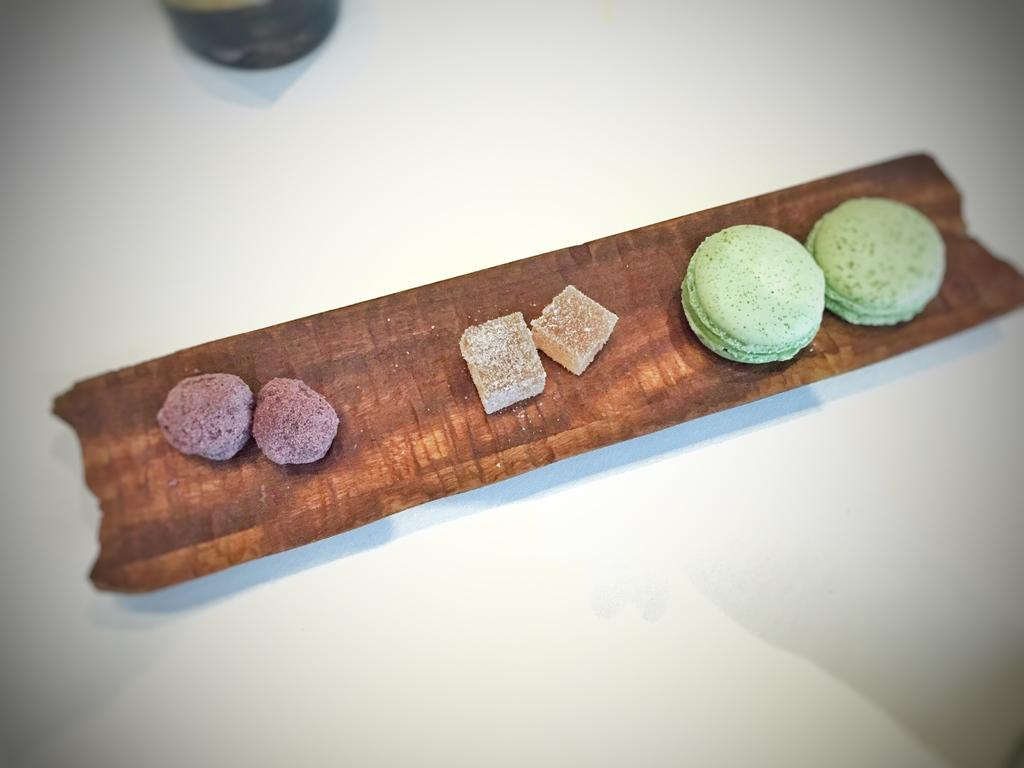What type of food can be seen in the image? There are cookies in the image. How are the cookies arranged or presented? The cookies are in a wooden tray. Where is the wooden tray with cookies located? The tray is on a table. What else can be seen on the table besides the cookies? There is a bottle visible in the image. What type of animal can be heard making a voice in the image? There is no animal or voice present in the image; it only shows cookies in a wooden tray on a table. 